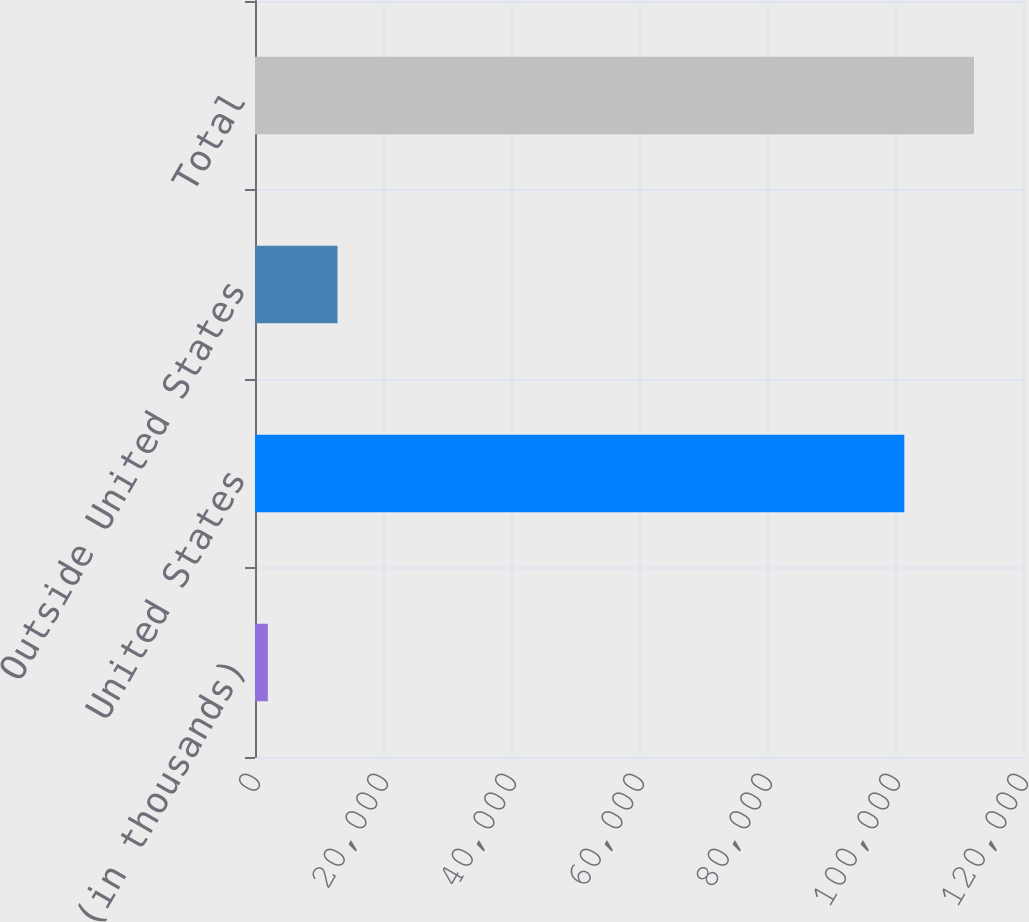<chart> <loc_0><loc_0><loc_500><loc_500><bar_chart><fcel>(in thousands)<fcel>United States<fcel>Outside United States<fcel>Total<nl><fcel>2002<fcel>101454<fcel>12890.1<fcel>112342<nl></chart> 